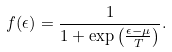Convert formula to latex. <formula><loc_0><loc_0><loc_500><loc_500>f ( \epsilon ) = \frac { 1 } { 1 + \exp \left ( \frac { \epsilon - \mu } { T } \right ) } .</formula> 